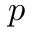<formula> <loc_0><loc_0><loc_500><loc_500>p</formula> 